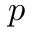<formula> <loc_0><loc_0><loc_500><loc_500>p</formula> 